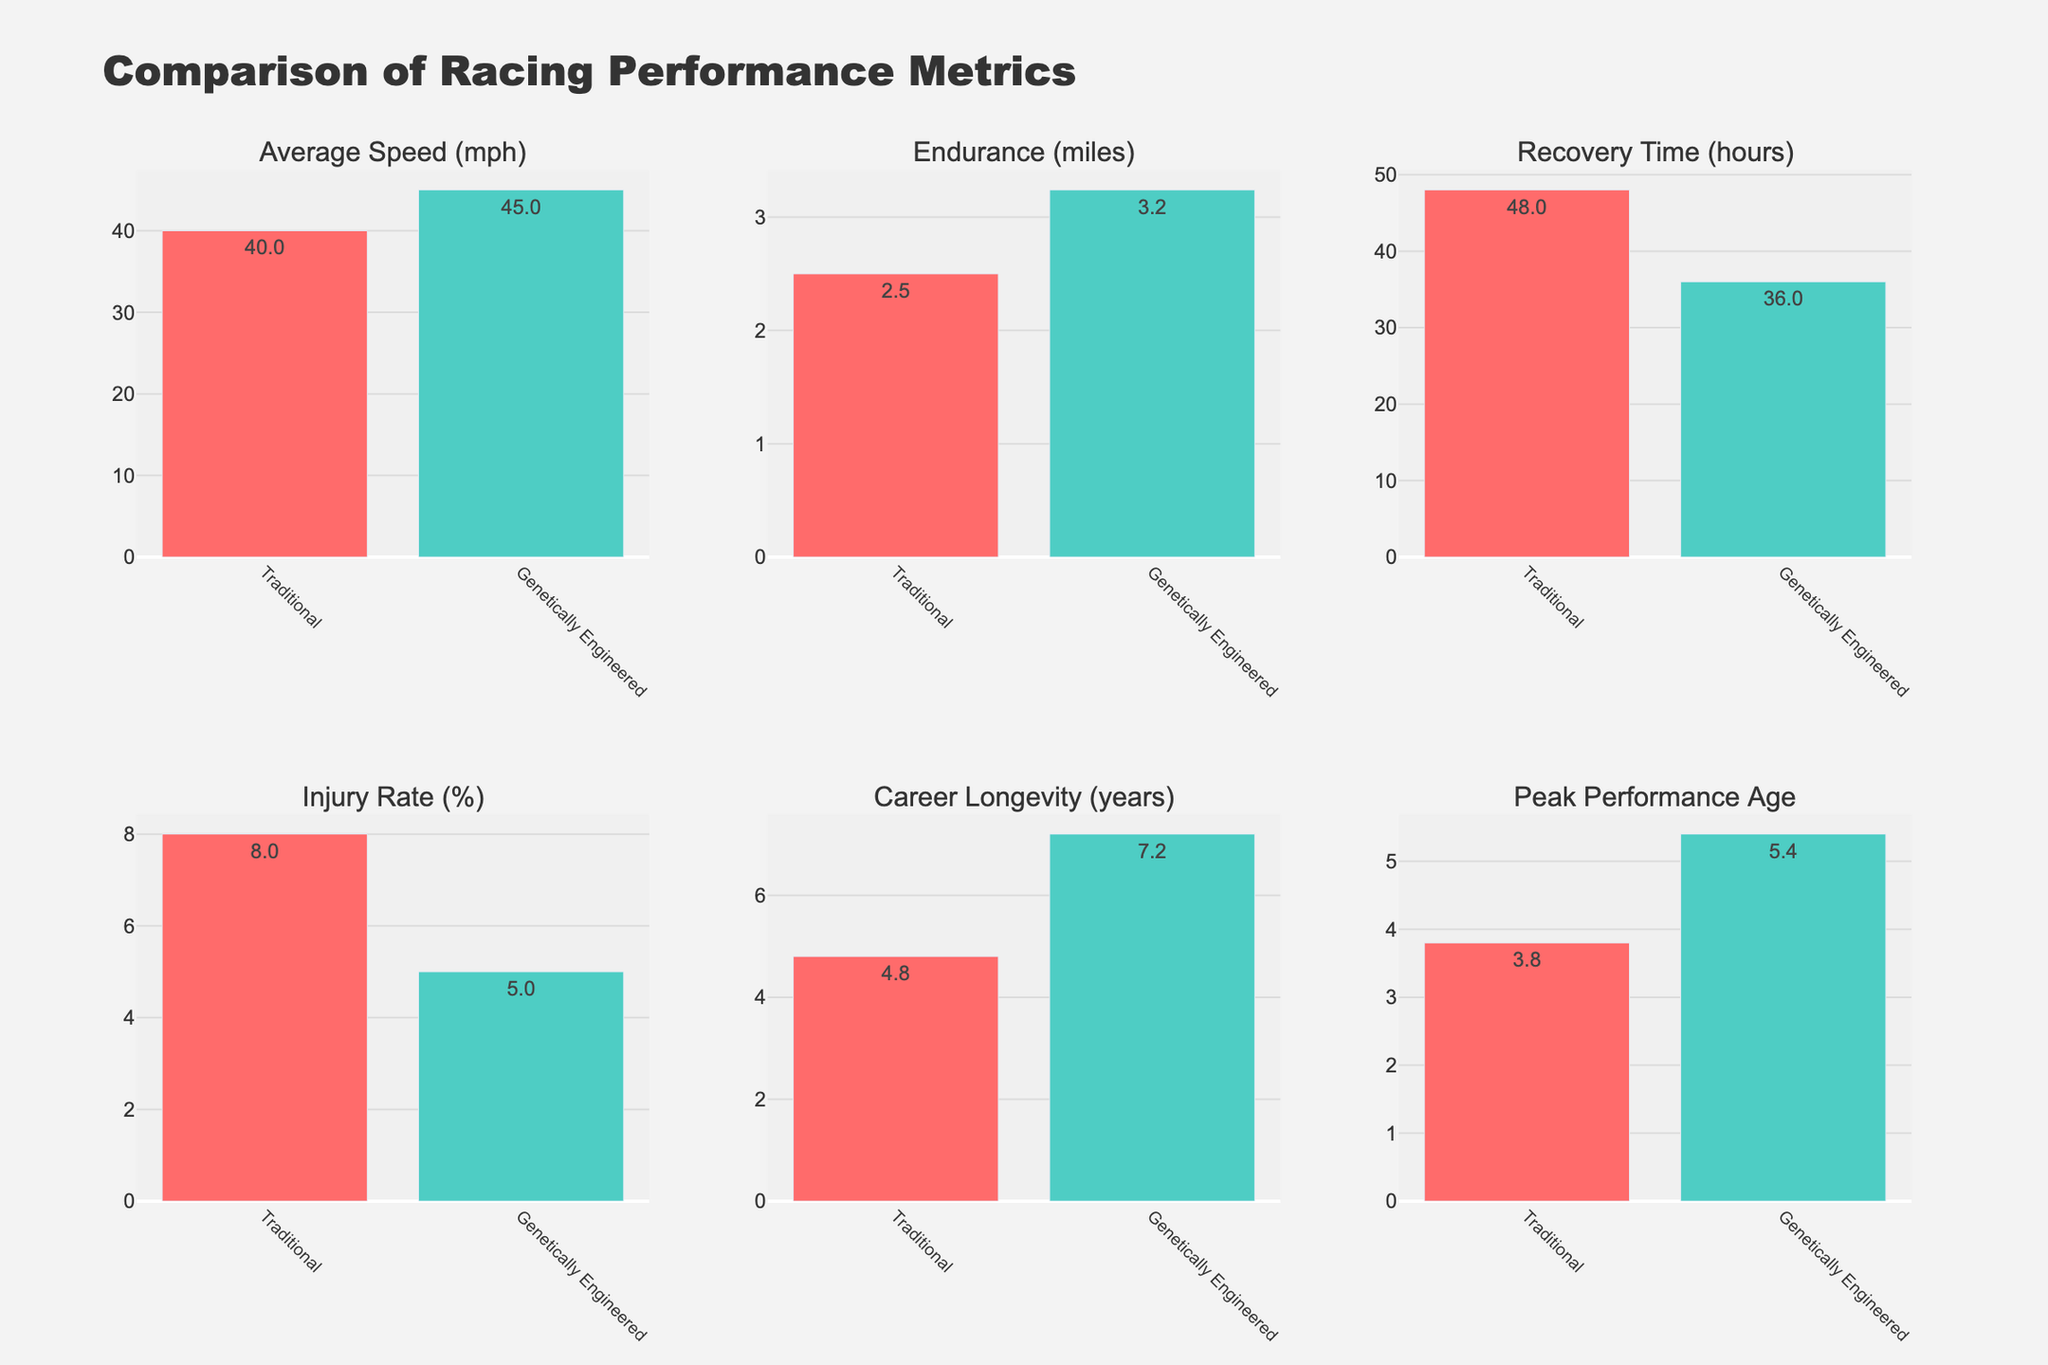**Question 1**: Which horse type has a higher average speed? The bar representing the average speed for Genetically Engineered racehorses is higher than that for Traditional racehorses. Genetically Engineered racehorses have an average speed of around 45 mph, while Traditional racehorses have an average speed of around 40 mph.
Answer: Genetically Engineered **Question 2**: What is the difference in endurance between traditional and genetically engineered racehorses? The endurance for Traditional racehorses is 2.5 miles, whereas for Genetically Engineered racehorses it is 3.2 miles. The difference is calculated as 3.2 - 2.5.
Answer: 0.7 miles **Question 3**: Which horse type has a lower injury rate? The bar representing the injury rate for Genetically Engineered racehorses is lower than that for Traditional racehorses. Genetically Engineered racehorses have an injury rate of around 5%, while Traditional racehorses have an injury rate of around 8%.
Answer: Genetically Engineered **Question 4**: How much shorter is the recovery time for genetically engineered racehorses compared to traditional ones? The recovery time for Traditional racehorses is 48 hours, whereas for Genetically Engineered racehorses, it is 36 hours. The difference is calculated as 48 - 36.
Answer: 12 hours **Question 5**: What is the average career longevity for both horse types? The career longevity for Traditional racehorses is 5 years, and for Genetically Engineered racehorses, it is 7 years. The average (mean) is calculated as (5 + 7)/2.
Answer: 6 years **Question 6**: Which horse type reaches their peak performance age later? The bars for the peak performance age for Traditional racehorses and Genetically Engineered racehorses both indicate a peak performance age of around 5 years for Genetically Engineered and around 4 years for Traditional racehorses.
Answer: Genetically Engineered **Question 7**: Compare the heights of the bars for average speed. Which is taller and by how much? The average speed for Traditional racehorses is 40 mph, and for Genetically Engineered racehorses, it is 45 mph. The difference is 45 - 40. By comparing the height of the bars visually, the genetically engineered one is taller by this value.
Answer: 5 mph **Question 8**: What's the combined value of the endurance for both horse types? The endurance for Traditional racehorses is 2.5 miles, and for Genetically Engineered racehorses, it is 3.2 miles. The sum is 2.5 + 3.2.
Answer: 5.7 miles **Question 9**: How does the peak performance age compare between the two horse types visually? The bar for the peak performance age of Genetically Engineered racehorses is slightly higher than that for Traditional racehorses. The genetically engineered horses reach their peak performance around 5 years, while the traditional ones reach it around 4 years.
Answer: Genetically Engineered reach it later **Question 10**: What are the values for Injury Rate (%) for both horse types? From the figure, the injury rate for Traditional racehorses is 8%, and for Genetically Engineered racehorses, it is 5%. The values can be directly read from the bar heights labeled with these percentages.
Answer: 8% for Traditional, 5% for Genetically Engineered 